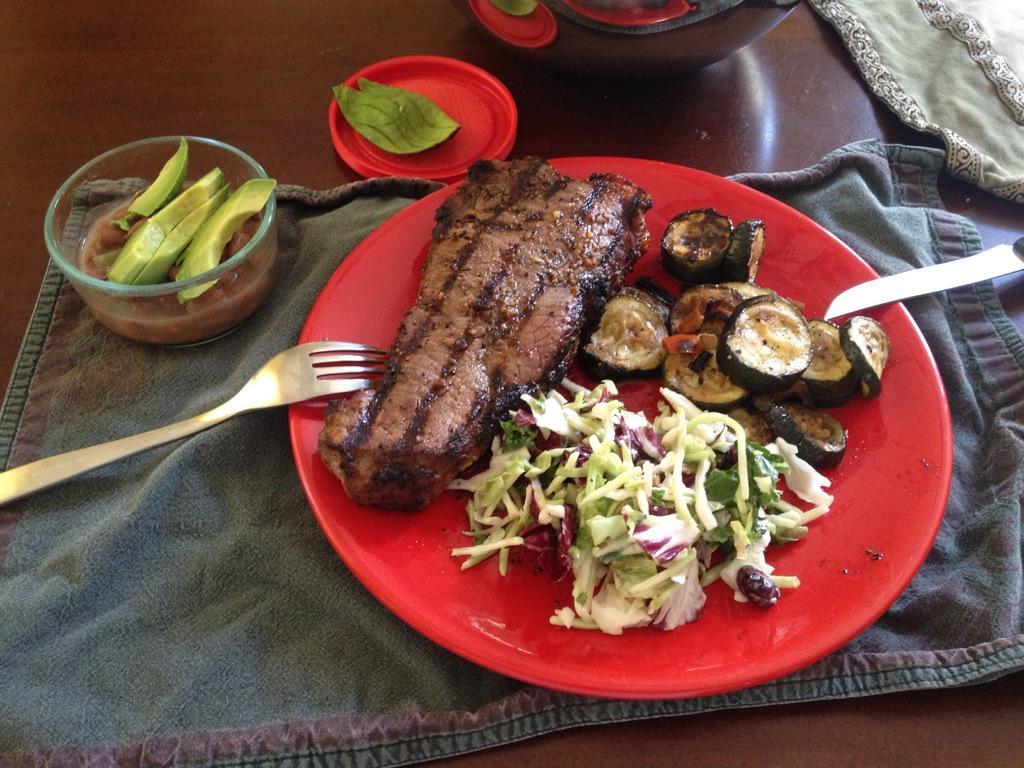Could you give a brief overview of what you see in this image? This is a zoomed in picture. In the center there is a wooden table on the top of which a platter containing some food items is placed and we can see a bowl of food and a fork, knife and some other objects are placed on the top of the table. 